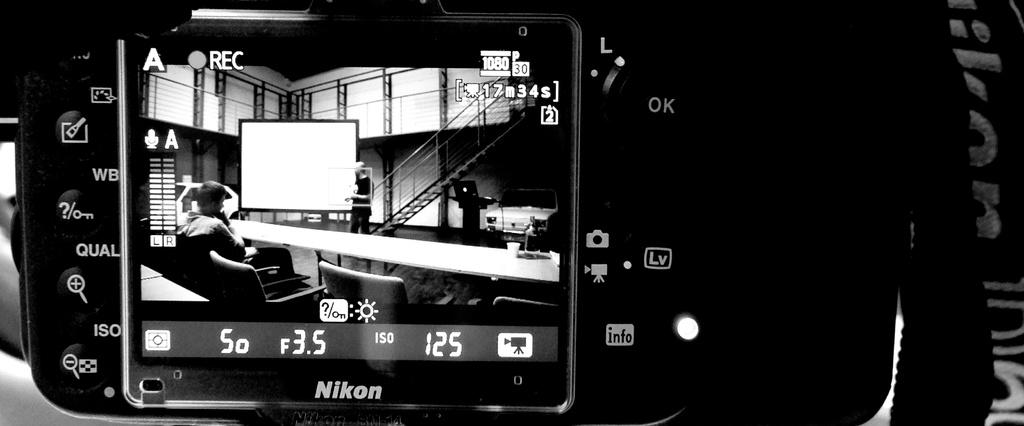What is the main subject of the image? The main subject of the image is a camera. Where is the camera tag located in the image? The camera tag is on the right side of the image. What can be seen on the camera screen? The camera screen displays chairs, a bench, people, a car, a building, and a projector screen. What type of bee is buzzing around the camera in the image? There are no bees present in the image; it features a camera with a camera tag and a screen displaying various elements. 